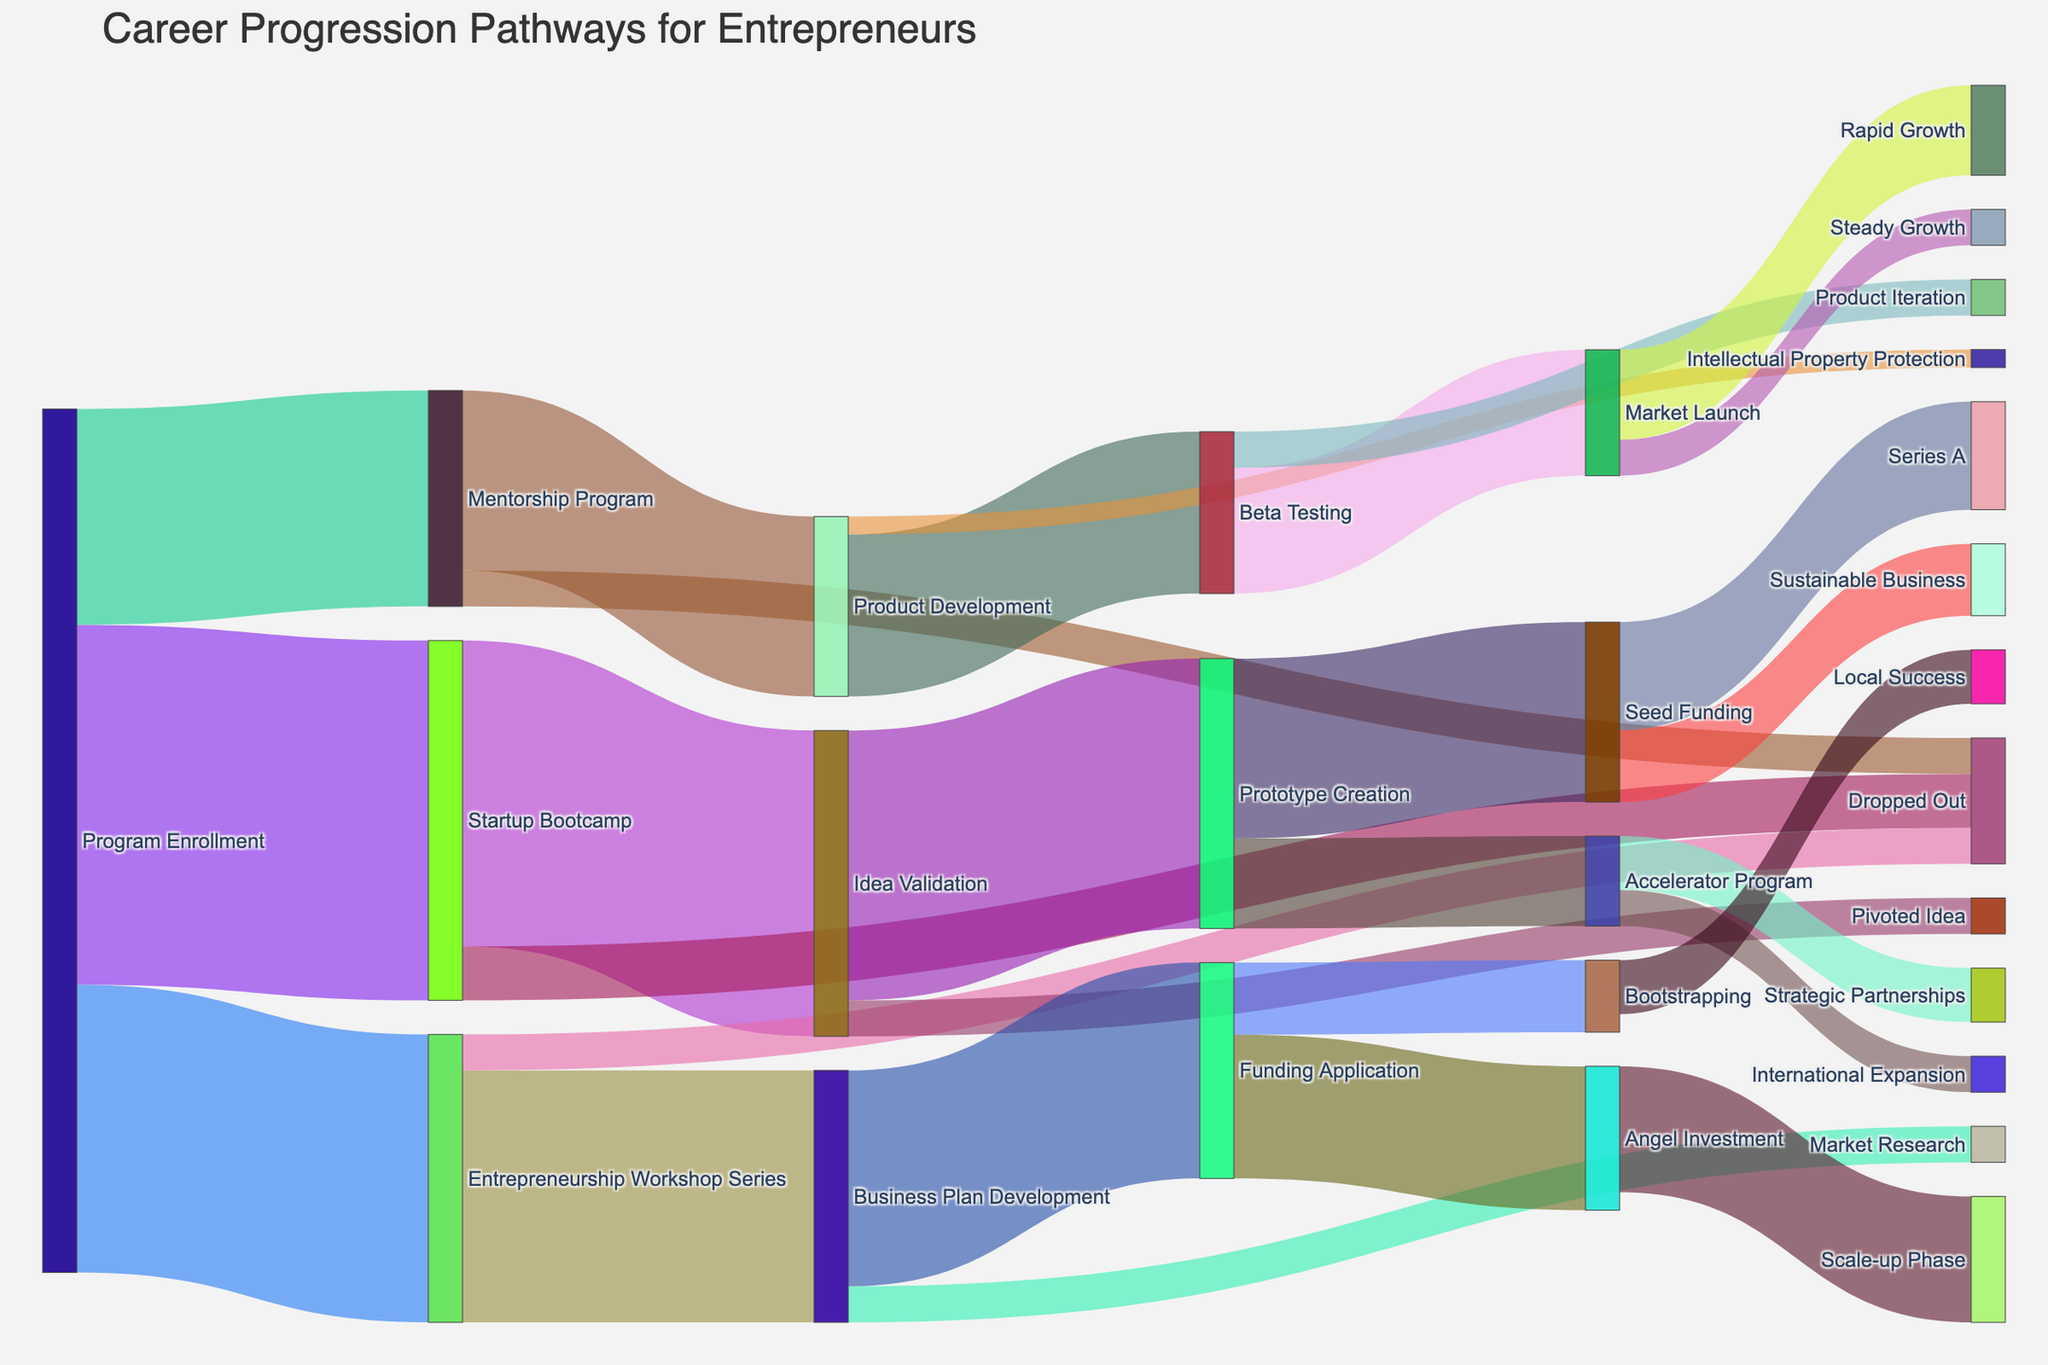what is the title of the figure? The title of the figure is mentioned at the top of the diagram. The large text at the top provides a clear label for the overall subject of the figure.
Answer: Career Progression Pathways for Entrepreneurs How many entrepreneurs enrolled in the Mentorship Program? From the diagram, trace the flow from 'Program Enrollment' to 'Mentorship Program'. The thickness of the link and the value label provide this information.
Answer: 60 Which stage has the highest dropout rate? Compare the flow that leads to 'Dropped Out' in each stage. We have three paths to compare: Startup Bootcamp to Dropped Out (15), Entrepreneurship Workshop Series to Dropped Out (10), and Mentorship Program to Dropped Out (10). The highest value indicates the highest dropout rate.
Answer: Startup Bootcamp How many entrepreneurs proceeded to the Idea Validation stage from Startup Bootcamp? Locate the link between 'Startup Bootcamp' and 'Idea Validation'. The thickness of the link and the value label provide this information.
Answer: 85 What is the total number of entrepreneurs who reached the stage after receiving Seed Funding? Identify the links that flow out from 'Seed Funding' to its subsequent stages. Sum the provided values of these links: Seed Funding to Series A (30) and Seed Funding to Sustainable Business (20).
Answer: 50 Compare the number of entrepreneurs moving from Product Development to Beta Testing with that from Prototype Creation to Seed Funding. Which pathway has more entrepreneurs? Locate the values for both links: Product Development to Beta Testing (45) and Prototype Creation to Seed Funding (50). Compare these values to determine which is greater.
Answer: Prototype Creation to Seed Funding What is the flow value from Funding Application to Angel Investment compared to Funding Application to Bootstrapping? Trace the links from 'Funding Application' to 'Angel Investment' (40) and 'Funding Application' to 'Bootstrapping' (20) and compare the values.
Answer: Angel Investment How many entrepreneurs reached the Market Launch stage? Identify the links that flow into 'Market Launch'. Sum the values for these links: Beta Testing to Market Launch (35).
Answer: 35 After attending the Entrepreneurship Workshop Series, how many entrepreneurs started Business Plan Development vs. Dropped Out? Locate the values for the links moving from 'Entrepreneurship Workshop Series' to 'Business Plan Development' (70) and to 'Dropped Out' (10). Compare these values.
Answer: Business Plan Development What fraction of entrepreneurs who enrolled in the Startup Bootcamp dropped out? Identify the total number in Startup Bootcamp (100) and the number who dropped out (15). The fraction is calculated as Dropped Out divided by total Startup Bootcamp enrollees, i.e., 15/100.
Answer: 0.15 